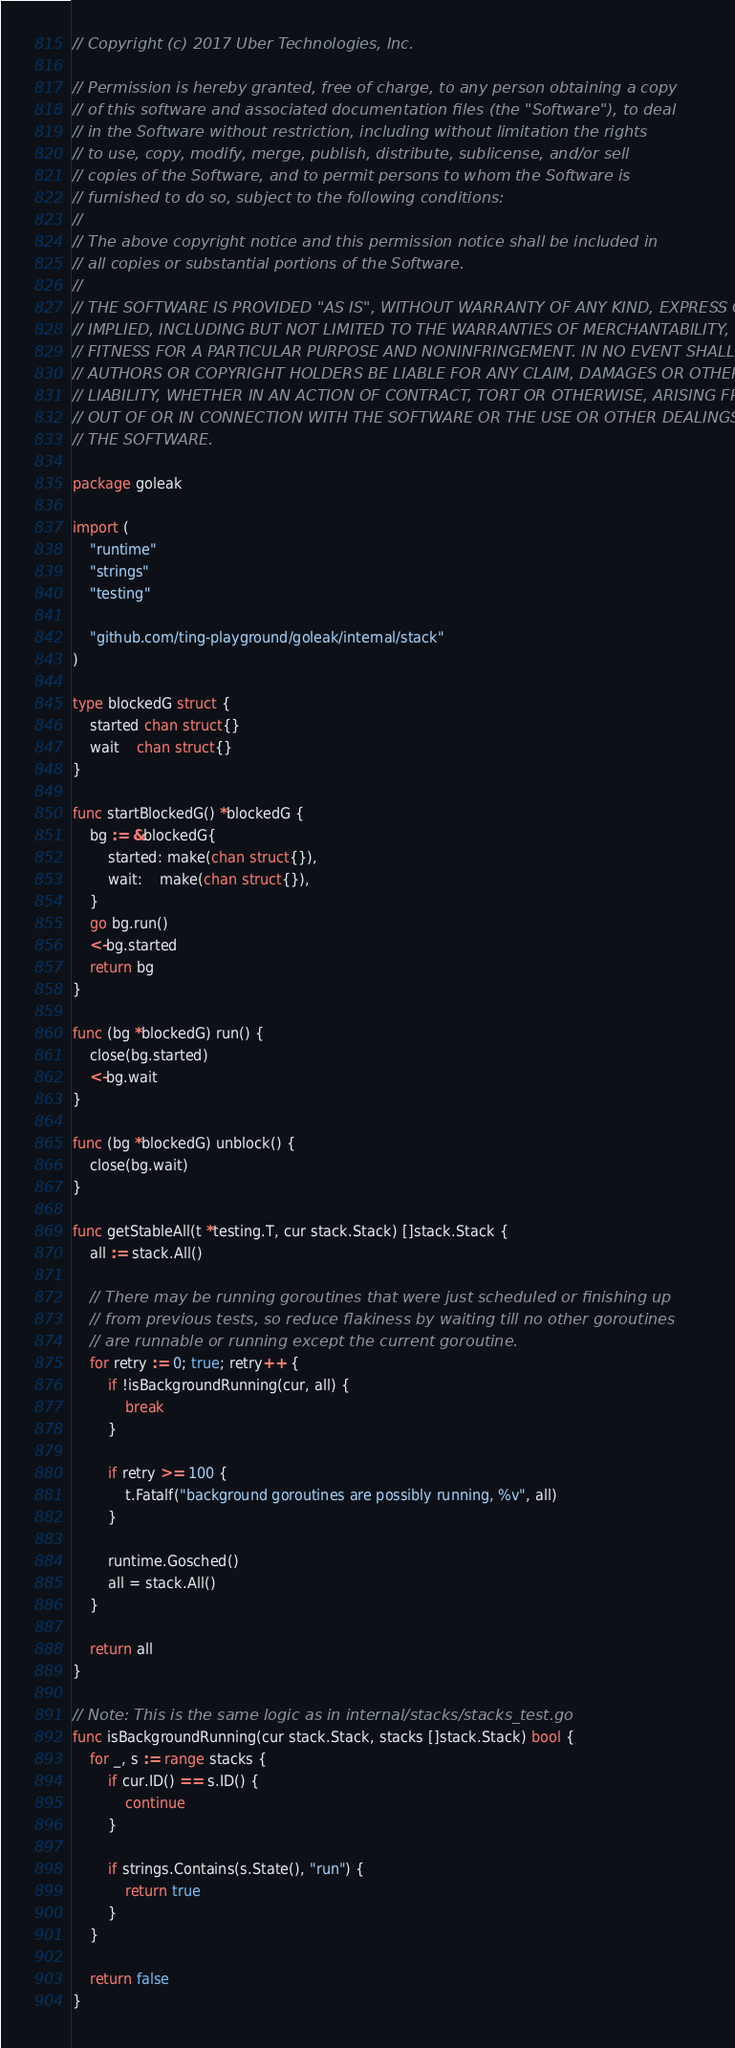Convert code to text. <code><loc_0><loc_0><loc_500><loc_500><_Go_>// Copyright (c) 2017 Uber Technologies, Inc.

// Permission is hereby granted, free of charge, to any person obtaining a copy
// of this software and associated documentation files (the "Software"), to deal
// in the Software without restriction, including without limitation the rights
// to use, copy, modify, merge, publish, distribute, sublicense, and/or sell
// copies of the Software, and to permit persons to whom the Software is
// furnished to do so, subject to the following conditions:
//
// The above copyright notice and this permission notice shall be included in
// all copies or substantial portions of the Software.
//
// THE SOFTWARE IS PROVIDED "AS IS", WITHOUT WARRANTY OF ANY KIND, EXPRESS OR
// IMPLIED, INCLUDING BUT NOT LIMITED TO THE WARRANTIES OF MERCHANTABILITY,
// FITNESS FOR A PARTICULAR PURPOSE AND NONINFRINGEMENT. IN NO EVENT SHALL THE
// AUTHORS OR COPYRIGHT HOLDERS BE LIABLE FOR ANY CLAIM, DAMAGES OR OTHER
// LIABILITY, WHETHER IN AN ACTION OF CONTRACT, TORT OR OTHERWISE, ARISING FROM,
// OUT OF OR IN CONNECTION WITH THE SOFTWARE OR THE USE OR OTHER DEALINGS IN
// THE SOFTWARE.

package goleak

import (
	"runtime"
	"strings"
	"testing"

	"github.com/ting-playground/goleak/internal/stack"
)

type blockedG struct {
	started chan struct{}
	wait    chan struct{}
}

func startBlockedG() *blockedG {
	bg := &blockedG{
		started: make(chan struct{}),
		wait:    make(chan struct{}),
	}
	go bg.run()
	<-bg.started
	return bg
}

func (bg *blockedG) run() {
	close(bg.started)
	<-bg.wait
}

func (bg *blockedG) unblock() {
	close(bg.wait)
}

func getStableAll(t *testing.T, cur stack.Stack) []stack.Stack {
	all := stack.All()

	// There may be running goroutines that were just scheduled or finishing up
	// from previous tests, so reduce flakiness by waiting till no other goroutines
	// are runnable or running except the current goroutine.
	for retry := 0; true; retry++ {
		if !isBackgroundRunning(cur, all) {
			break
		}

		if retry >= 100 {
			t.Fatalf("background goroutines are possibly running, %v", all)
		}

		runtime.Gosched()
		all = stack.All()
	}

	return all
}

// Note: This is the same logic as in internal/stacks/stacks_test.go
func isBackgroundRunning(cur stack.Stack, stacks []stack.Stack) bool {
	for _, s := range stacks {
		if cur.ID() == s.ID() {
			continue
		}

		if strings.Contains(s.State(), "run") {
			return true
		}
	}

	return false
}
</code> 